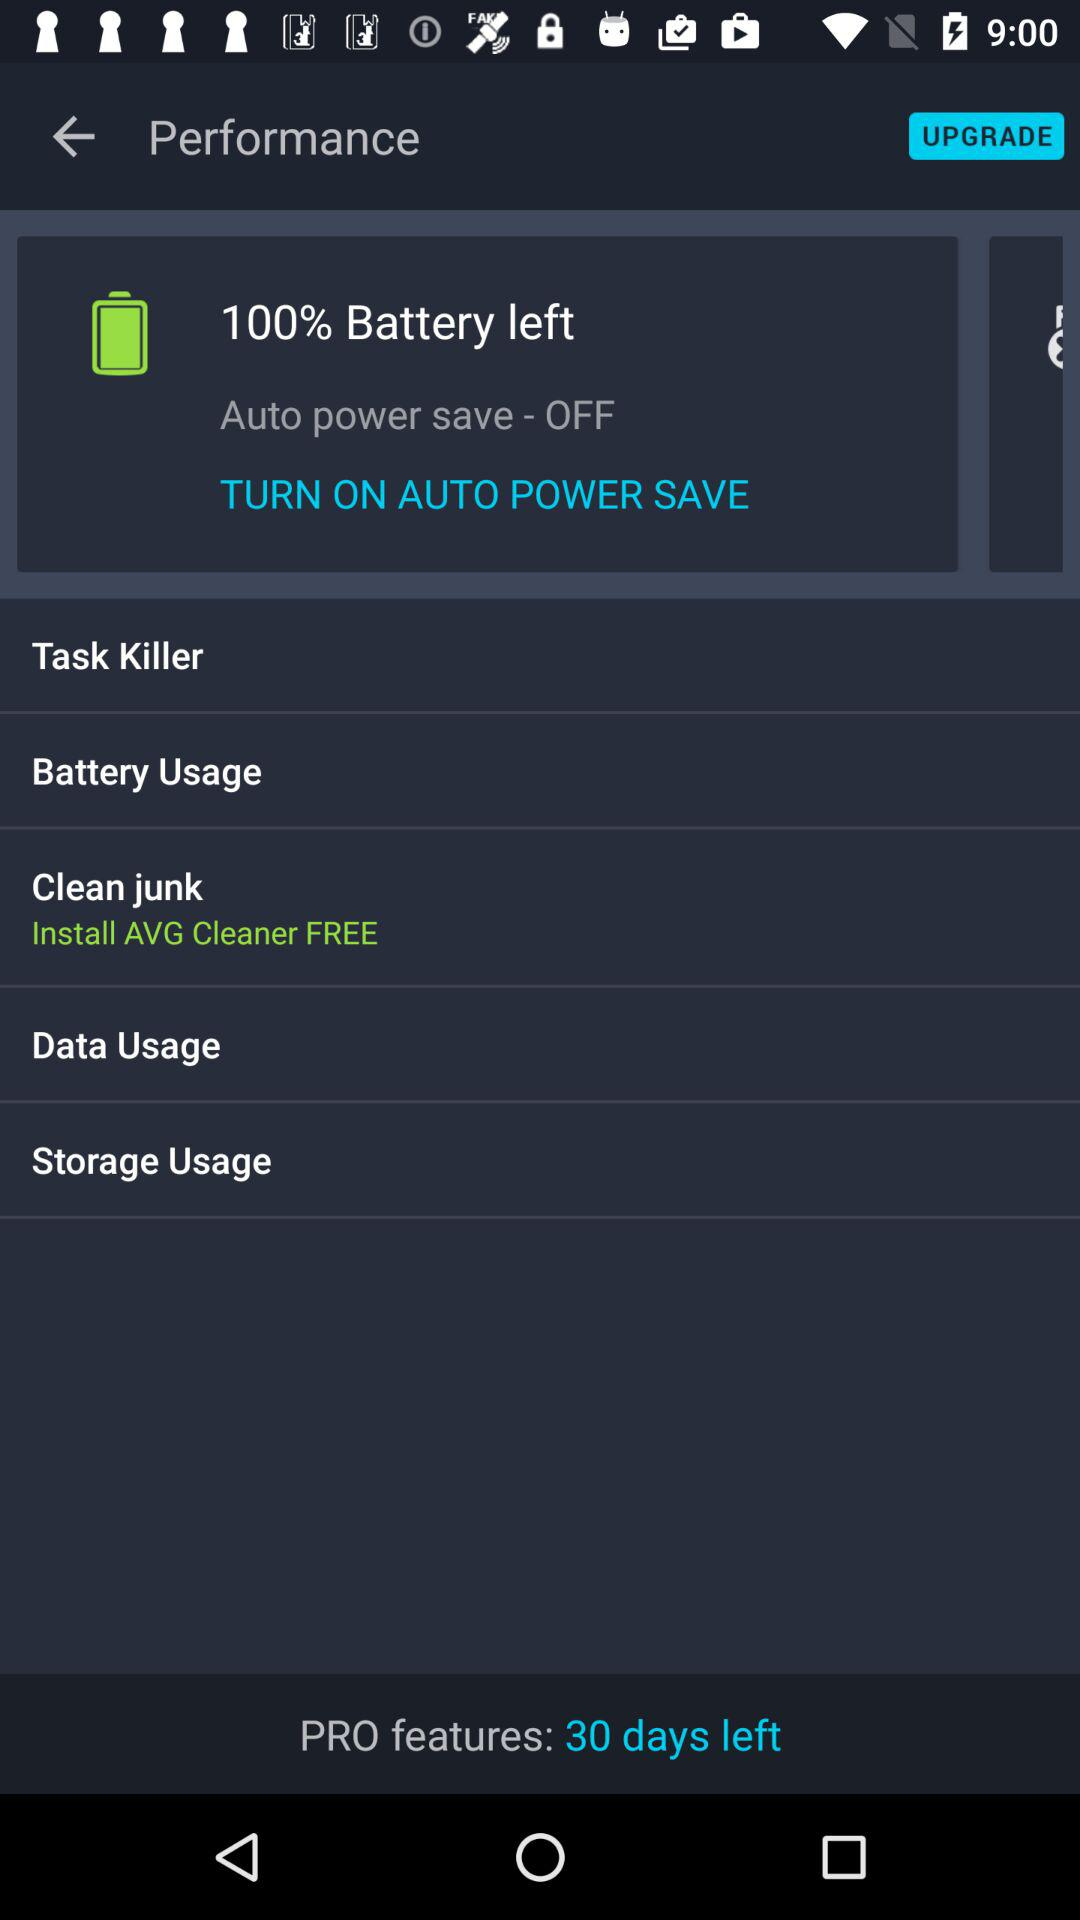What is the status of auto power save? The status is off. 